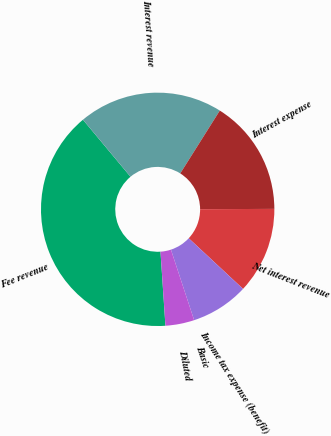Convert chart. <chart><loc_0><loc_0><loc_500><loc_500><pie_chart><fcel>Fee revenue<fcel>Interest revenue<fcel>Interest expense<fcel>Net interest revenue<fcel>Income tax expense (benefit)<fcel>Basic<fcel>Diluted<nl><fcel>40.0%<fcel>20.0%<fcel>16.0%<fcel>12.0%<fcel>8.0%<fcel>0.0%<fcel>4.0%<nl></chart> 